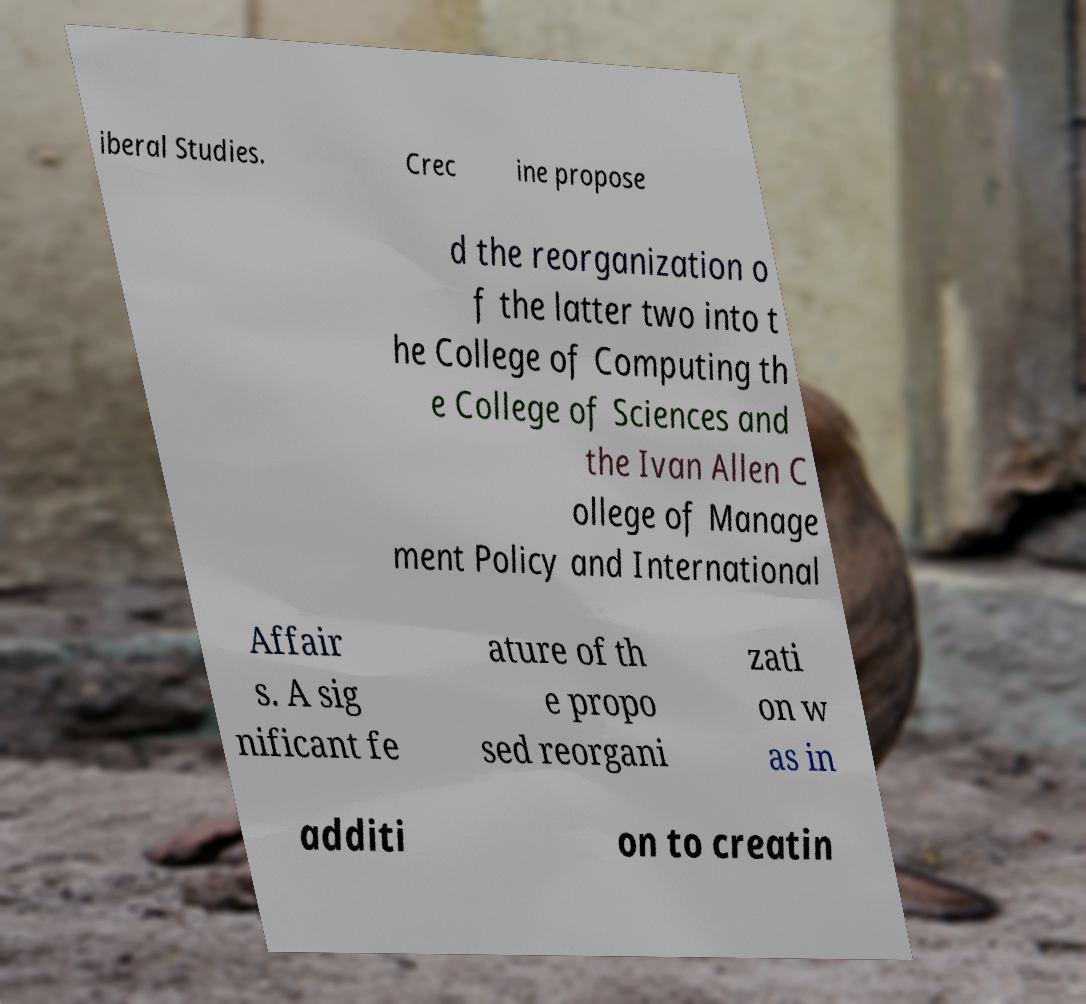Can you accurately transcribe the text from the provided image for me? iberal Studies. Crec ine propose d the reorganization o f the latter two into t he College of Computing th e College of Sciences and the Ivan Allen C ollege of Manage ment Policy and International Affair s. A sig nificant fe ature of th e propo sed reorgani zati on w as in additi on to creatin 